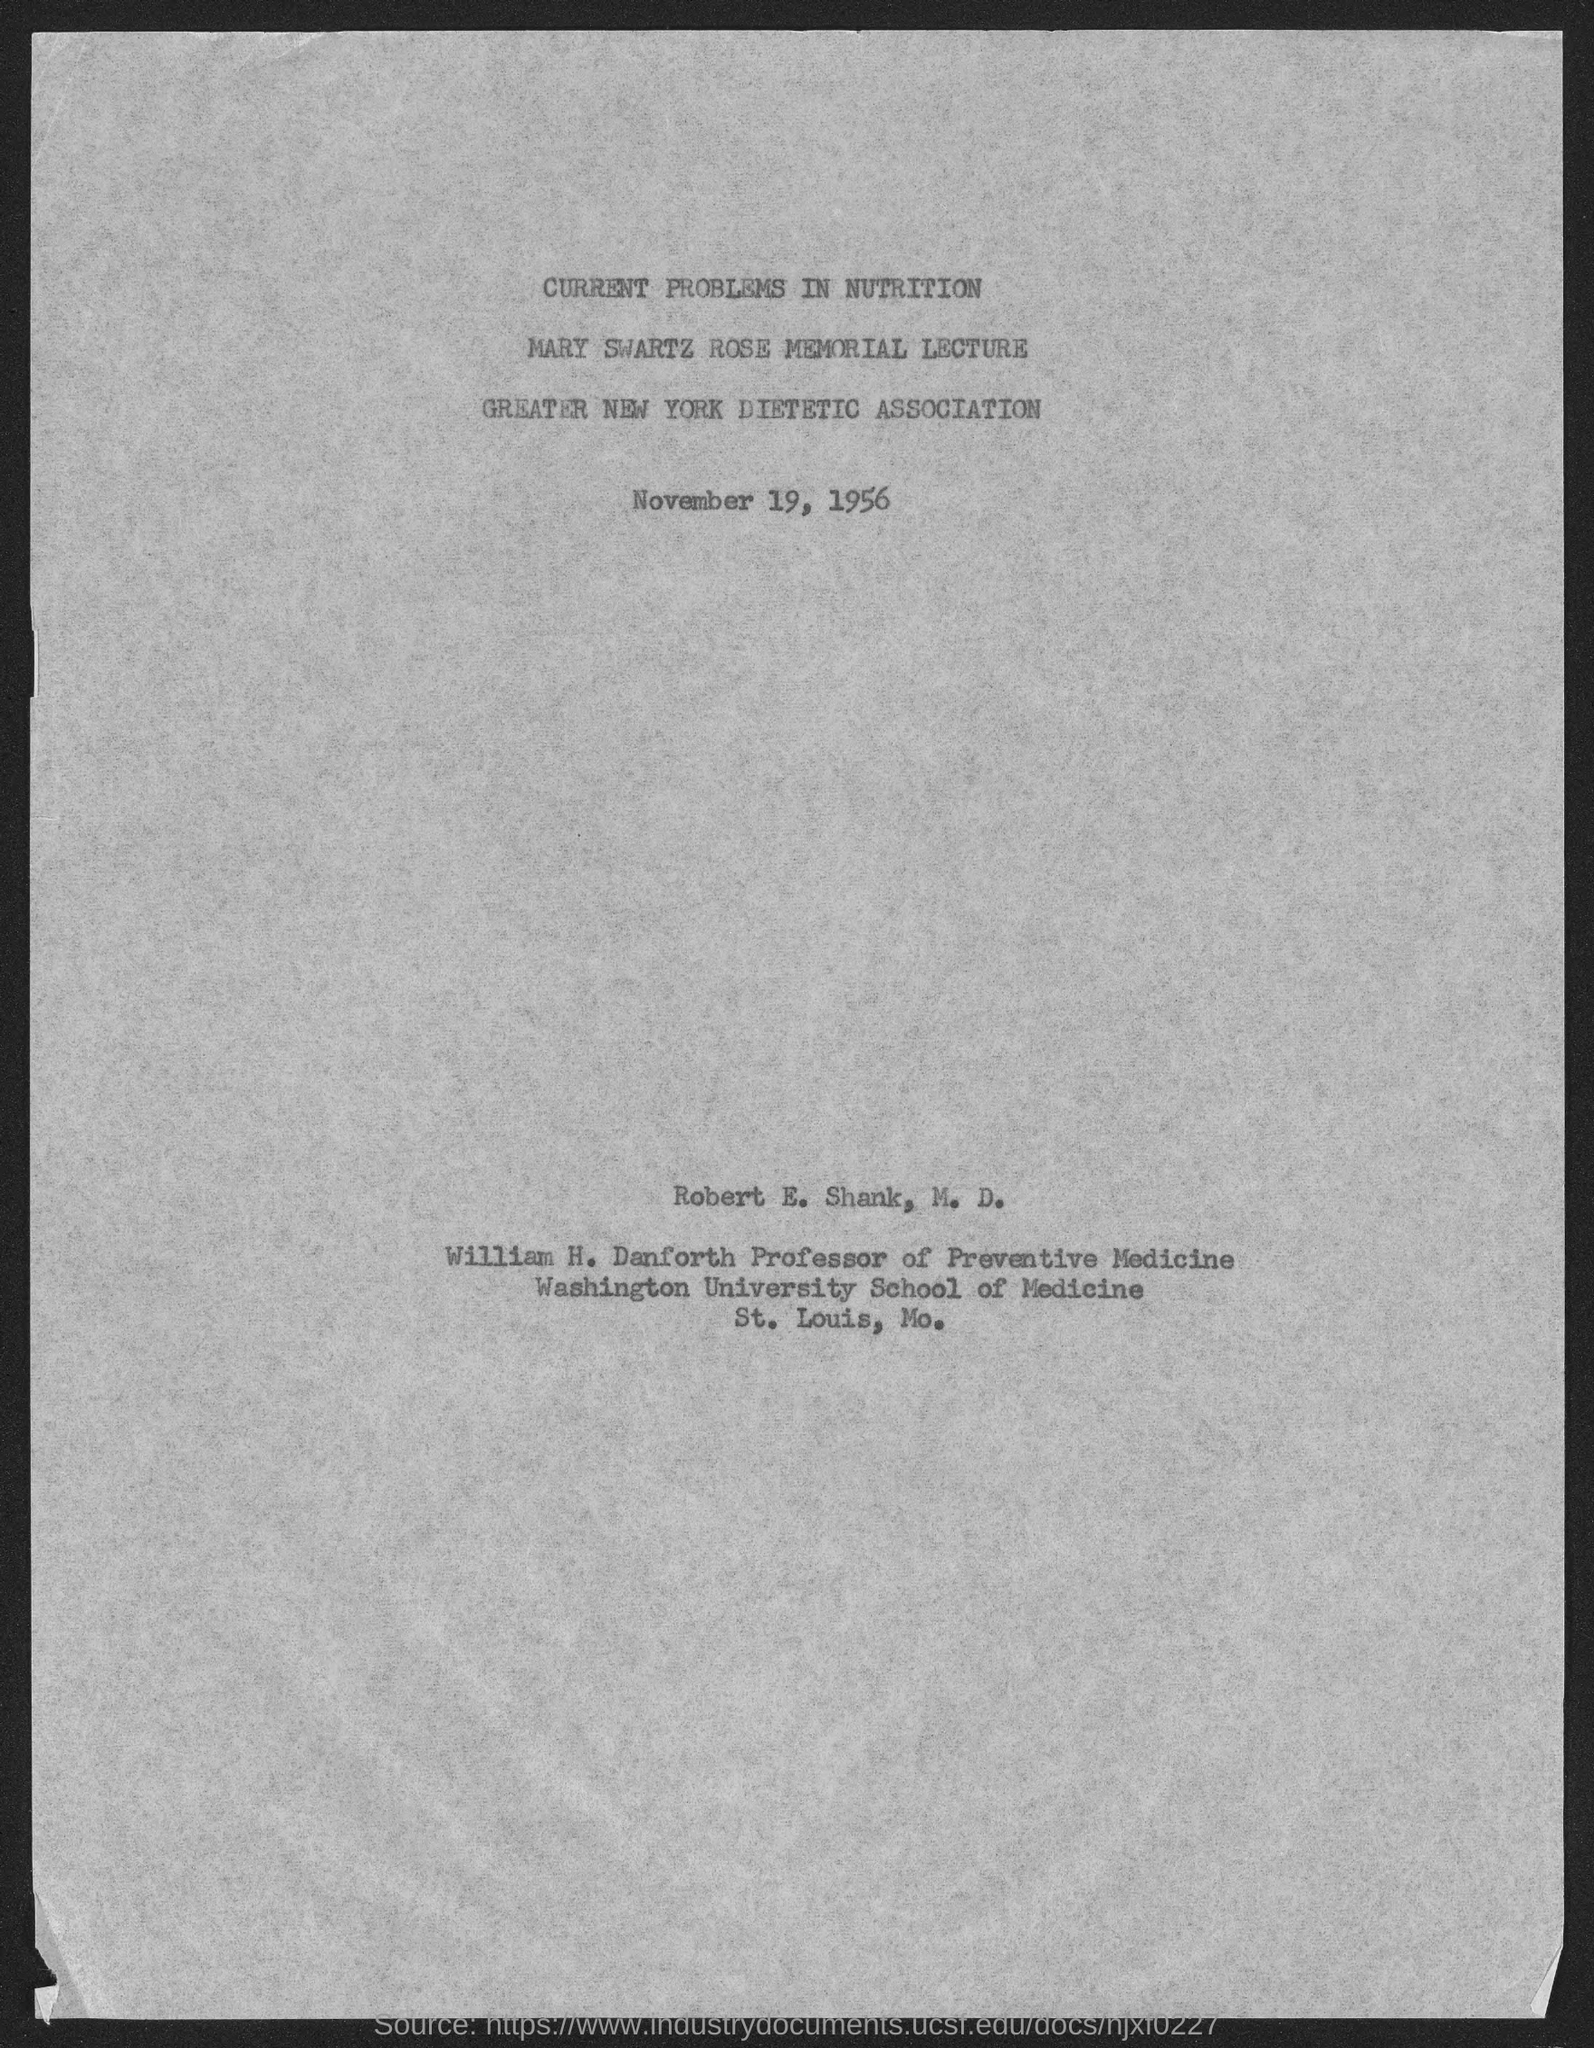When is Mary Swartz Rose Memorial Lecture on 'Current Problems in Nutrition' held?
Your answer should be compact. November 19, 1956. Who is the Professor of Preventive Medicine?
Ensure brevity in your answer.  William H. Danforth. 